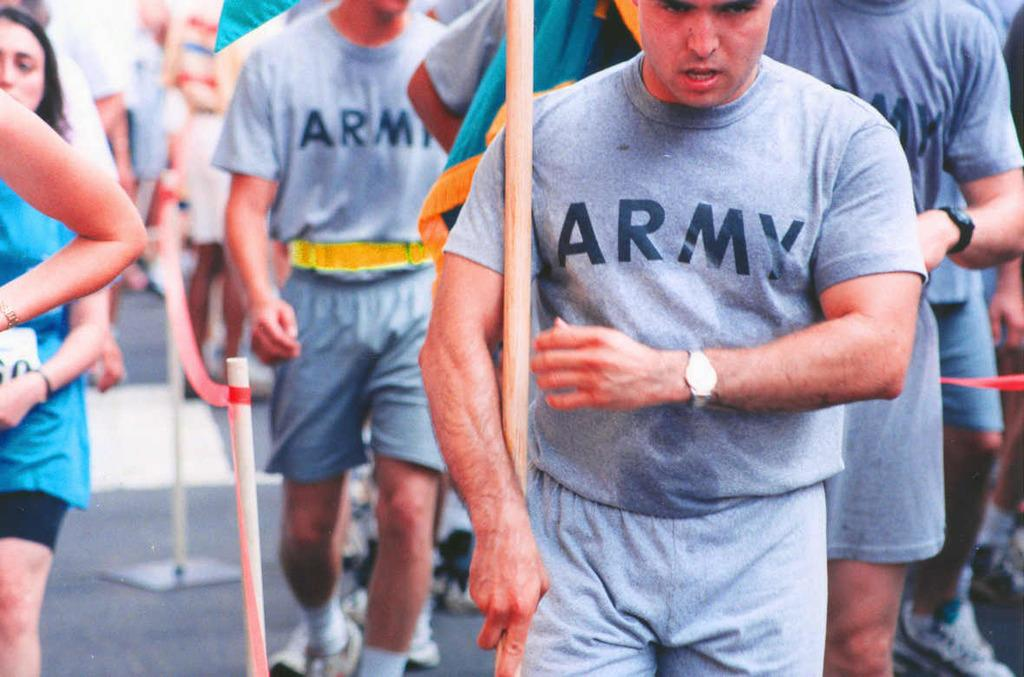<image>
Share a concise interpretation of the image provided. Many men wearing Army shirts march in a parade. 